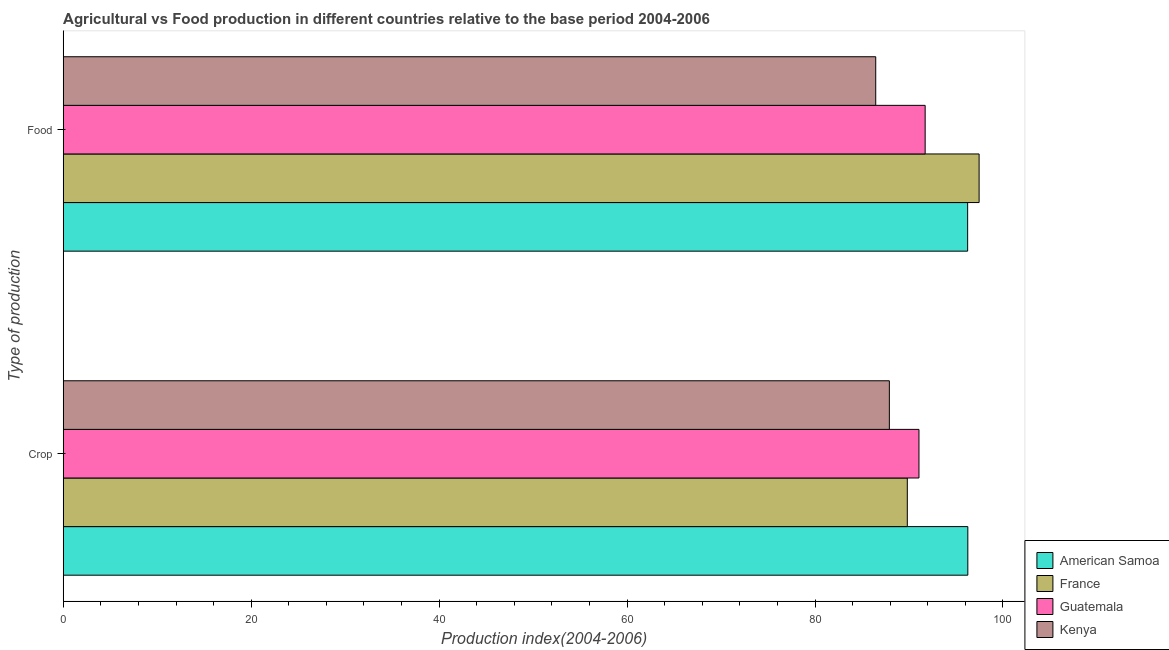Are the number of bars per tick equal to the number of legend labels?
Your response must be concise. Yes. Are the number of bars on each tick of the Y-axis equal?
Your answer should be compact. Yes. How many bars are there on the 2nd tick from the top?
Give a very brief answer. 4. What is the label of the 2nd group of bars from the top?
Provide a short and direct response. Crop. What is the crop production index in Kenya?
Provide a succinct answer. 87.91. Across all countries, what is the maximum food production index?
Your response must be concise. 97.46. Across all countries, what is the minimum crop production index?
Provide a succinct answer. 87.91. In which country was the food production index maximum?
Ensure brevity in your answer.  France. In which country was the food production index minimum?
Make the answer very short. Kenya. What is the total crop production index in the graph?
Offer a very short reply. 365.05. What is the difference between the food production index in France and the crop production index in Kenya?
Offer a terse response. 9.55. What is the average crop production index per country?
Ensure brevity in your answer.  91.26. What is the difference between the crop production index and food production index in Kenya?
Provide a succinct answer. 1.45. In how many countries, is the food production index greater than 92 ?
Give a very brief answer. 2. What is the ratio of the crop production index in Kenya to that in Guatemala?
Your response must be concise. 0.97. In how many countries, is the food production index greater than the average food production index taken over all countries?
Provide a short and direct response. 2. What does the 3rd bar from the top in Food represents?
Offer a very short reply. France. What does the 4th bar from the bottom in Crop represents?
Ensure brevity in your answer.  Kenya. How many countries are there in the graph?
Provide a succinct answer. 4. Are the values on the major ticks of X-axis written in scientific E-notation?
Your answer should be very brief. No. Does the graph contain grids?
Keep it short and to the point. No. Where does the legend appear in the graph?
Provide a succinct answer. Bottom right. How many legend labels are there?
Offer a terse response. 4. What is the title of the graph?
Provide a succinct answer. Agricultural vs Food production in different countries relative to the base period 2004-2006. What is the label or title of the X-axis?
Provide a succinct answer. Production index(2004-2006). What is the label or title of the Y-axis?
Provide a succinct answer. Type of production. What is the Production index(2004-2006) in American Samoa in Crop?
Offer a very short reply. 96.26. What is the Production index(2004-2006) in France in Crop?
Make the answer very short. 89.82. What is the Production index(2004-2006) in Guatemala in Crop?
Offer a terse response. 91.06. What is the Production index(2004-2006) of Kenya in Crop?
Ensure brevity in your answer.  87.91. What is the Production index(2004-2006) of American Samoa in Food?
Ensure brevity in your answer.  96.24. What is the Production index(2004-2006) in France in Food?
Your response must be concise. 97.46. What is the Production index(2004-2006) in Guatemala in Food?
Your answer should be very brief. 91.72. What is the Production index(2004-2006) of Kenya in Food?
Offer a very short reply. 86.46. Across all Type of production, what is the maximum Production index(2004-2006) in American Samoa?
Your answer should be compact. 96.26. Across all Type of production, what is the maximum Production index(2004-2006) in France?
Make the answer very short. 97.46. Across all Type of production, what is the maximum Production index(2004-2006) of Guatemala?
Provide a short and direct response. 91.72. Across all Type of production, what is the maximum Production index(2004-2006) in Kenya?
Keep it short and to the point. 87.91. Across all Type of production, what is the minimum Production index(2004-2006) of American Samoa?
Ensure brevity in your answer.  96.24. Across all Type of production, what is the minimum Production index(2004-2006) in France?
Keep it short and to the point. 89.82. Across all Type of production, what is the minimum Production index(2004-2006) of Guatemala?
Your answer should be very brief. 91.06. Across all Type of production, what is the minimum Production index(2004-2006) in Kenya?
Offer a very short reply. 86.46. What is the total Production index(2004-2006) in American Samoa in the graph?
Your response must be concise. 192.5. What is the total Production index(2004-2006) in France in the graph?
Your answer should be very brief. 187.28. What is the total Production index(2004-2006) of Guatemala in the graph?
Make the answer very short. 182.78. What is the total Production index(2004-2006) in Kenya in the graph?
Your answer should be compact. 174.37. What is the difference between the Production index(2004-2006) of American Samoa in Crop and that in Food?
Your answer should be compact. 0.02. What is the difference between the Production index(2004-2006) in France in Crop and that in Food?
Make the answer very short. -7.64. What is the difference between the Production index(2004-2006) of Guatemala in Crop and that in Food?
Ensure brevity in your answer.  -0.66. What is the difference between the Production index(2004-2006) of Kenya in Crop and that in Food?
Provide a short and direct response. 1.45. What is the difference between the Production index(2004-2006) in American Samoa in Crop and the Production index(2004-2006) in Guatemala in Food?
Offer a terse response. 4.54. What is the difference between the Production index(2004-2006) in American Samoa in Crop and the Production index(2004-2006) in Kenya in Food?
Provide a short and direct response. 9.8. What is the difference between the Production index(2004-2006) in France in Crop and the Production index(2004-2006) in Kenya in Food?
Keep it short and to the point. 3.36. What is the difference between the Production index(2004-2006) of Guatemala in Crop and the Production index(2004-2006) of Kenya in Food?
Keep it short and to the point. 4.6. What is the average Production index(2004-2006) of American Samoa per Type of production?
Keep it short and to the point. 96.25. What is the average Production index(2004-2006) of France per Type of production?
Provide a short and direct response. 93.64. What is the average Production index(2004-2006) of Guatemala per Type of production?
Offer a very short reply. 91.39. What is the average Production index(2004-2006) in Kenya per Type of production?
Your response must be concise. 87.19. What is the difference between the Production index(2004-2006) in American Samoa and Production index(2004-2006) in France in Crop?
Provide a short and direct response. 6.44. What is the difference between the Production index(2004-2006) of American Samoa and Production index(2004-2006) of Kenya in Crop?
Give a very brief answer. 8.35. What is the difference between the Production index(2004-2006) in France and Production index(2004-2006) in Guatemala in Crop?
Make the answer very short. -1.24. What is the difference between the Production index(2004-2006) in France and Production index(2004-2006) in Kenya in Crop?
Your answer should be very brief. 1.91. What is the difference between the Production index(2004-2006) in Guatemala and Production index(2004-2006) in Kenya in Crop?
Offer a terse response. 3.15. What is the difference between the Production index(2004-2006) of American Samoa and Production index(2004-2006) of France in Food?
Provide a succinct answer. -1.22. What is the difference between the Production index(2004-2006) of American Samoa and Production index(2004-2006) of Guatemala in Food?
Ensure brevity in your answer.  4.52. What is the difference between the Production index(2004-2006) in American Samoa and Production index(2004-2006) in Kenya in Food?
Provide a succinct answer. 9.78. What is the difference between the Production index(2004-2006) in France and Production index(2004-2006) in Guatemala in Food?
Ensure brevity in your answer.  5.74. What is the difference between the Production index(2004-2006) in France and Production index(2004-2006) in Kenya in Food?
Make the answer very short. 11. What is the difference between the Production index(2004-2006) in Guatemala and Production index(2004-2006) in Kenya in Food?
Provide a succinct answer. 5.26. What is the ratio of the Production index(2004-2006) in France in Crop to that in Food?
Provide a short and direct response. 0.92. What is the ratio of the Production index(2004-2006) of Kenya in Crop to that in Food?
Ensure brevity in your answer.  1.02. What is the difference between the highest and the second highest Production index(2004-2006) of American Samoa?
Provide a succinct answer. 0.02. What is the difference between the highest and the second highest Production index(2004-2006) in France?
Keep it short and to the point. 7.64. What is the difference between the highest and the second highest Production index(2004-2006) of Guatemala?
Offer a very short reply. 0.66. What is the difference between the highest and the second highest Production index(2004-2006) of Kenya?
Offer a very short reply. 1.45. What is the difference between the highest and the lowest Production index(2004-2006) in American Samoa?
Your answer should be very brief. 0.02. What is the difference between the highest and the lowest Production index(2004-2006) in France?
Your answer should be very brief. 7.64. What is the difference between the highest and the lowest Production index(2004-2006) in Guatemala?
Ensure brevity in your answer.  0.66. What is the difference between the highest and the lowest Production index(2004-2006) in Kenya?
Provide a short and direct response. 1.45. 